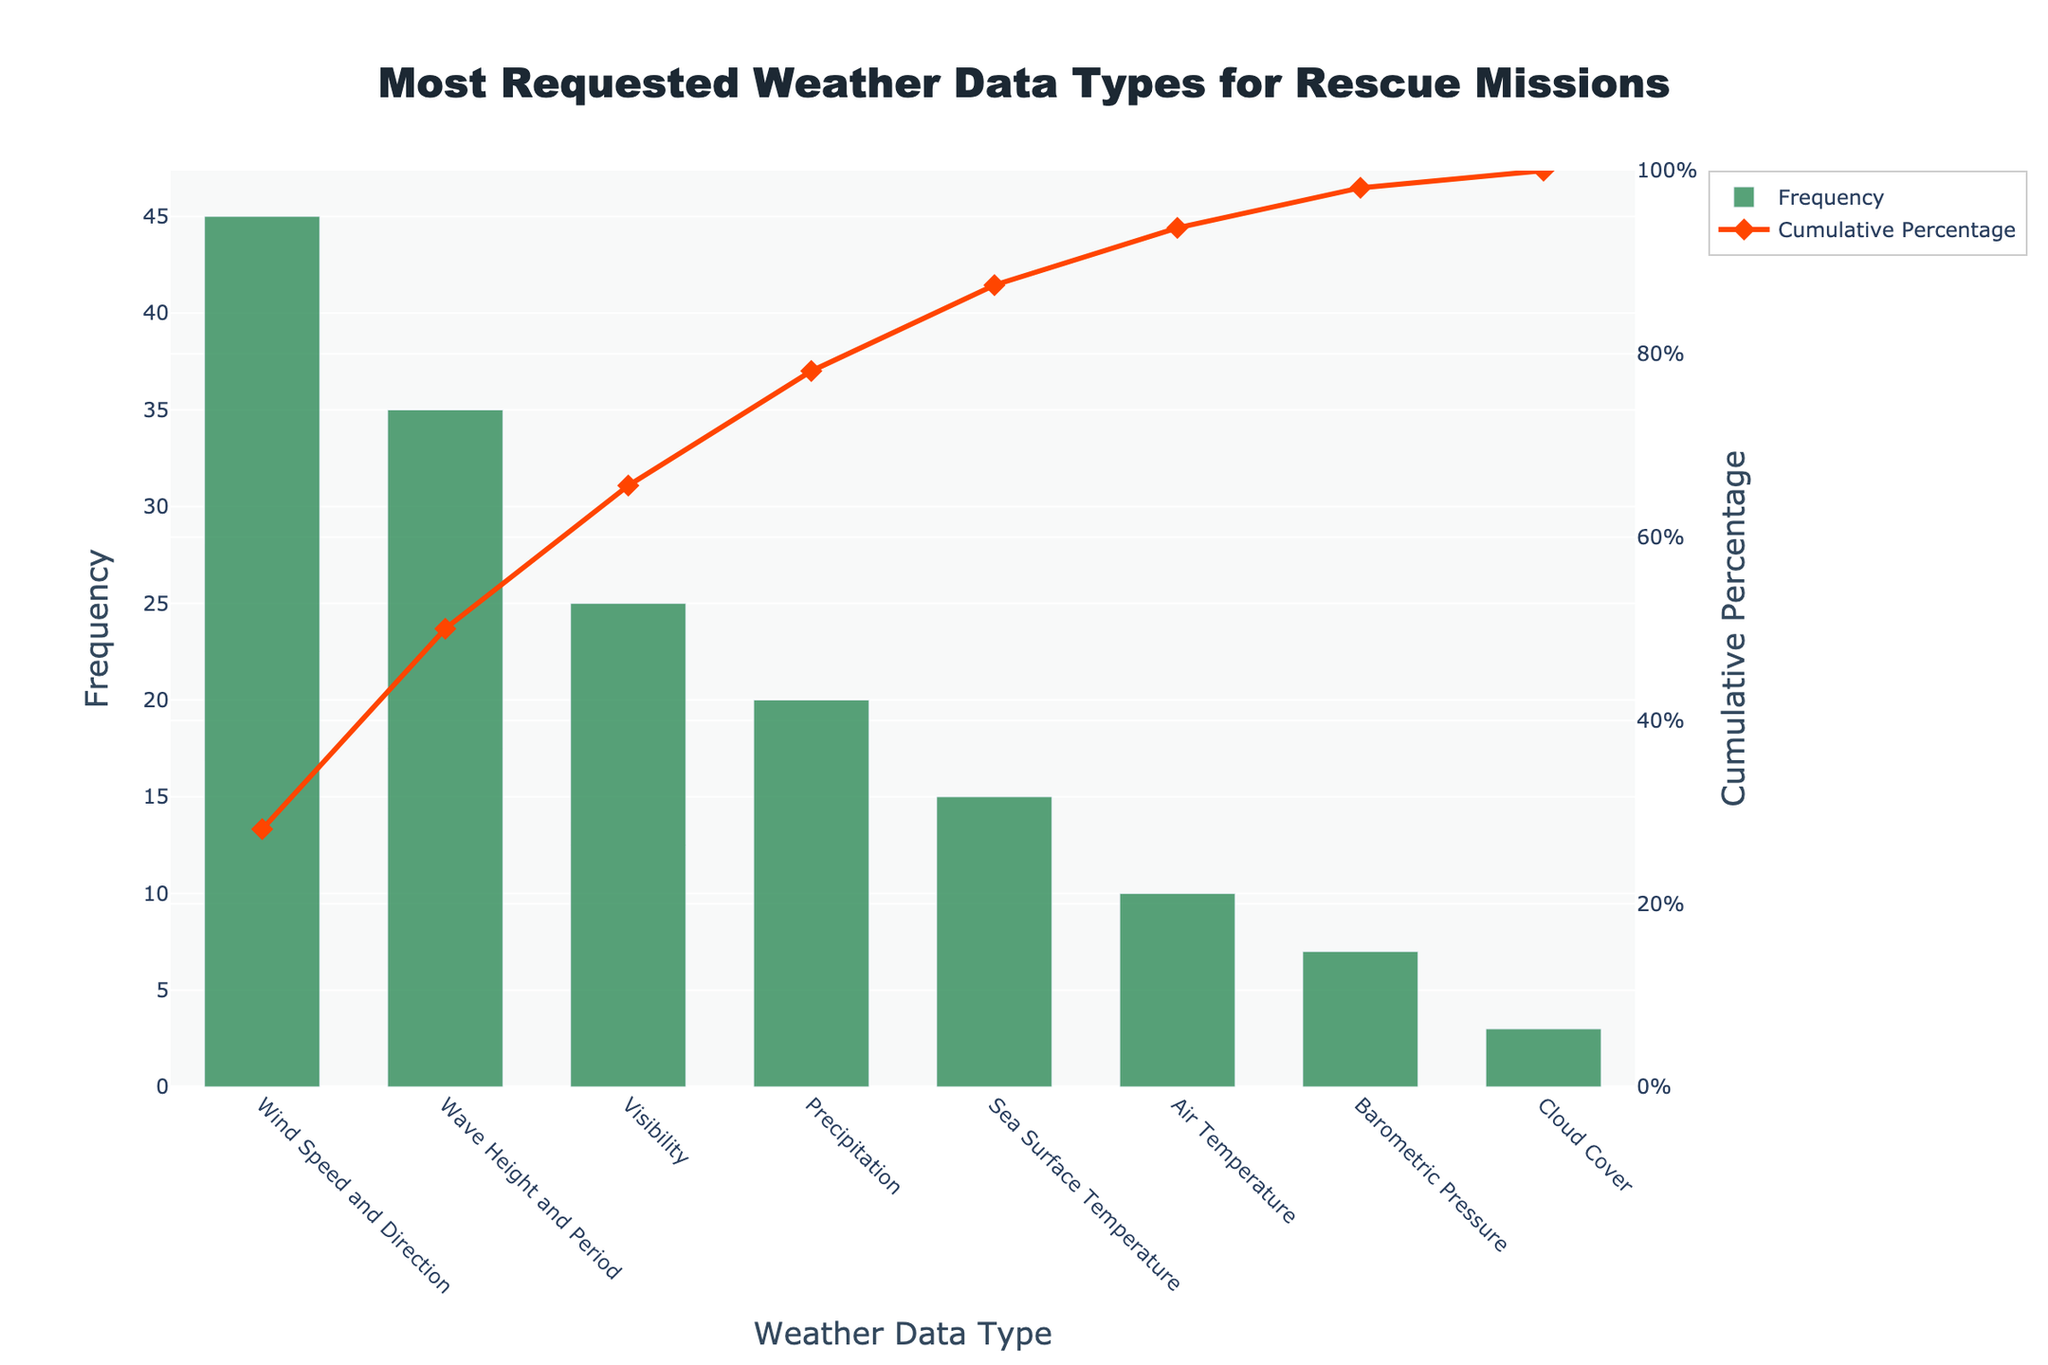What's the title of the figure? The title is located at the top of the figure and reads "Most Requested Weather Data Types for Rescue Missions"
Answer: Most Requested Weather Data Types for Rescue Missions Which weather data type has the highest frequency? The weather data type with the highest bar and the first in the list is 'Wind Speed and Direction', indicating it has the highest frequency
Answer: Wind Speed and Direction What is the cumulative percentage for 'Wave Height and Period'? The cumulative percentage for 'Wave Height and Period' is noted in the corresponding row on the y2 axis where 'Wave Height and Period' is situated
Answer: 50.00% Which weather data type contributes exactly to the 100% cumulative percentage? The cumulative percentage reaches 100.00% at the end of the list, which corresponds to 'Cloud Cover'
Answer: Cloud Cover How many weather data types are included in the figure? The number of distinct weather data types is equivalent to the number of bars (or points on the x-axis), which sum up to 8
Answer: 8 What is the combined frequency of 'Air Temperature' and 'Barometric Pressure'? The frequencies of 'Air Temperature' and 'Barometric Pressure' are 10 and 7, respectively, summing them yields 17
Answer: 17 What is the difference in cumulative percentage between 'Visibility' and 'Precipitation'? 'Visibility' has a cumulative percentage of 65.63%, and 'Precipitation' has 78.13%. Subtracting these percentages gives the difference: 78.13% - 65.63%
Answer: 12.5% Which weather data type has the lowest frequency, and what is the frequency value? The lowest bar corresponds to 'Cloud Cover', with a frequency value of 3
Answer: Cloud Cover, 3 What cumulative percentage range does 'Sea Surface Temperature' fall under? 'Sea Surface Temperature' falls under a cumulative percentage between 78.13% and 87.50%, inclusive
Answer: 78.13% to 87.50% Which contributes more to the cumulative percentage: 'Wave Height and Period' or 'Visibility'? 'Wave Height and Period' contributes 21.87% (50.00% - 28.13%), while 'Visibility' contributes 15.63% (65.63% - 50.00%). Hence, 'Wave Height and Period' contributes more
Answer: Wave Height and Period 